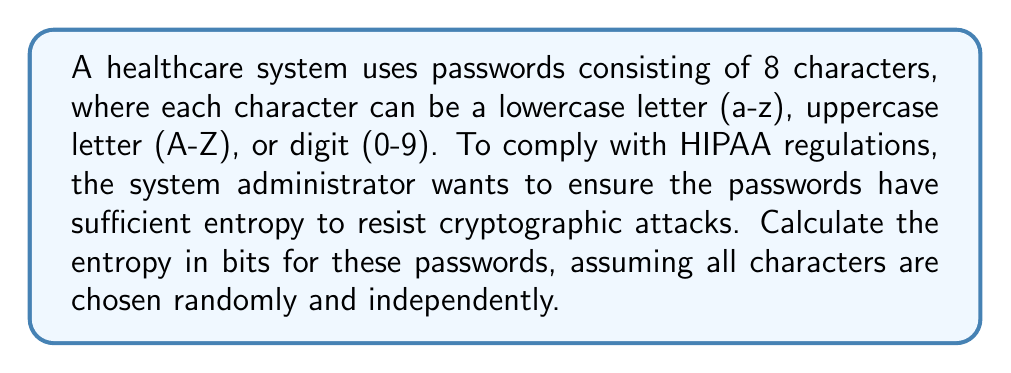Give your solution to this math problem. To calculate the entropy of the passwords, we'll follow these steps:

1. Determine the number of possible characters:
   - Lowercase letters: 26
   - Uppercase letters: 26
   - Digits: 10
   Total: 26 + 26 + 10 = 62 possible characters

2. Calculate the number of possible passwords:
   $$ N = 62^8 $$
   (62 choices for each of the 8 character positions)

3. Calculate the entropy using the formula:
   $$ H = \log_2(N) $$

   Where:
   $H$ is the entropy in bits
   $N$ is the number of possible passwords

4. Substitute the values:
   $$ H = \log_2(62^8) $$

5. Use the logarithm property $\log_a(x^n) = n \log_a(x)$:
   $$ H = 8 \log_2(62) $$

6. Calculate the result:
   $$ H = 8 \times 5.954196310386875 \approx 47.63357048309500 \text{ bits} $$

As a medical malpractice attorney, you should be aware that NIST guidelines recommend a minimum entropy of 30 bits for passwords in healthcare systems to be considered sufficiently strong against cryptographic attacks.
Answer: 47.63 bits 